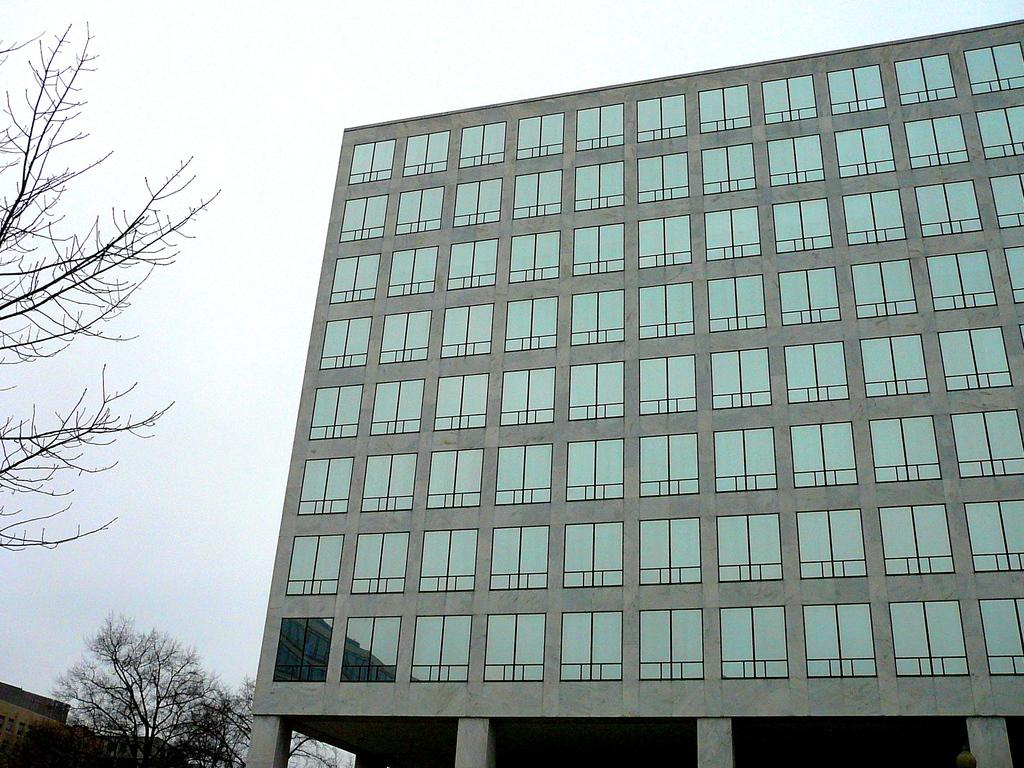What type of structure is present in the picture? There is a building in the picture. What can be seen in the bottom left corner of the image? Trees and another building are visible in the bottom left corner of the image. What is visible at the top of the image? The sky is visible at the top of the image. What type of chalk is being used to draw on the building in the image? There is no chalk or drawing present on the building in the image. How many pears are visible on the trees in the bottom left corner of the image? There are no pears visible on the trees in the image; only trees are present. 